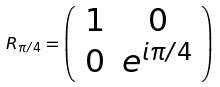Convert formula to latex. <formula><loc_0><loc_0><loc_500><loc_500>R _ { \pi / 4 } = \left ( \begin{array} { c c } 1 & 0 \\ 0 & e ^ { i \pi / 4 } \end{array} \right )</formula> 